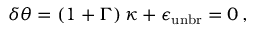Convert formula to latex. <formula><loc_0><loc_0><loc_500><loc_500>\delta \theta = \left ( 1 + \Gamma \right ) \kappa + \epsilon _ { u n b r } = 0 \, ,</formula> 